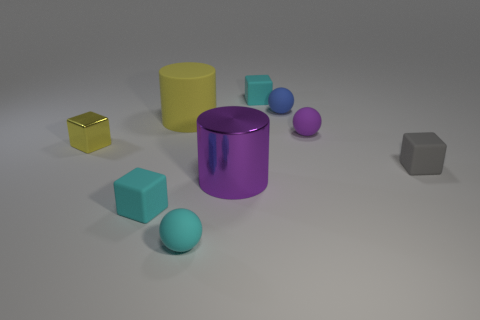Subtract all tiny gray cubes. How many cubes are left? 3 Add 1 matte cylinders. How many objects exist? 10 Subtract all purple cylinders. How many cylinders are left? 1 Subtract all cylinders. How many objects are left? 7 Subtract all purple cylinders. How many cyan blocks are left? 2 Add 8 big objects. How many big objects exist? 10 Subtract 1 purple balls. How many objects are left? 8 Subtract 4 blocks. How many blocks are left? 0 Subtract all purple cubes. Subtract all cyan spheres. How many cubes are left? 4 Subtract all yellow rubber things. Subtract all tiny blue rubber balls. How many objects are left? 7 